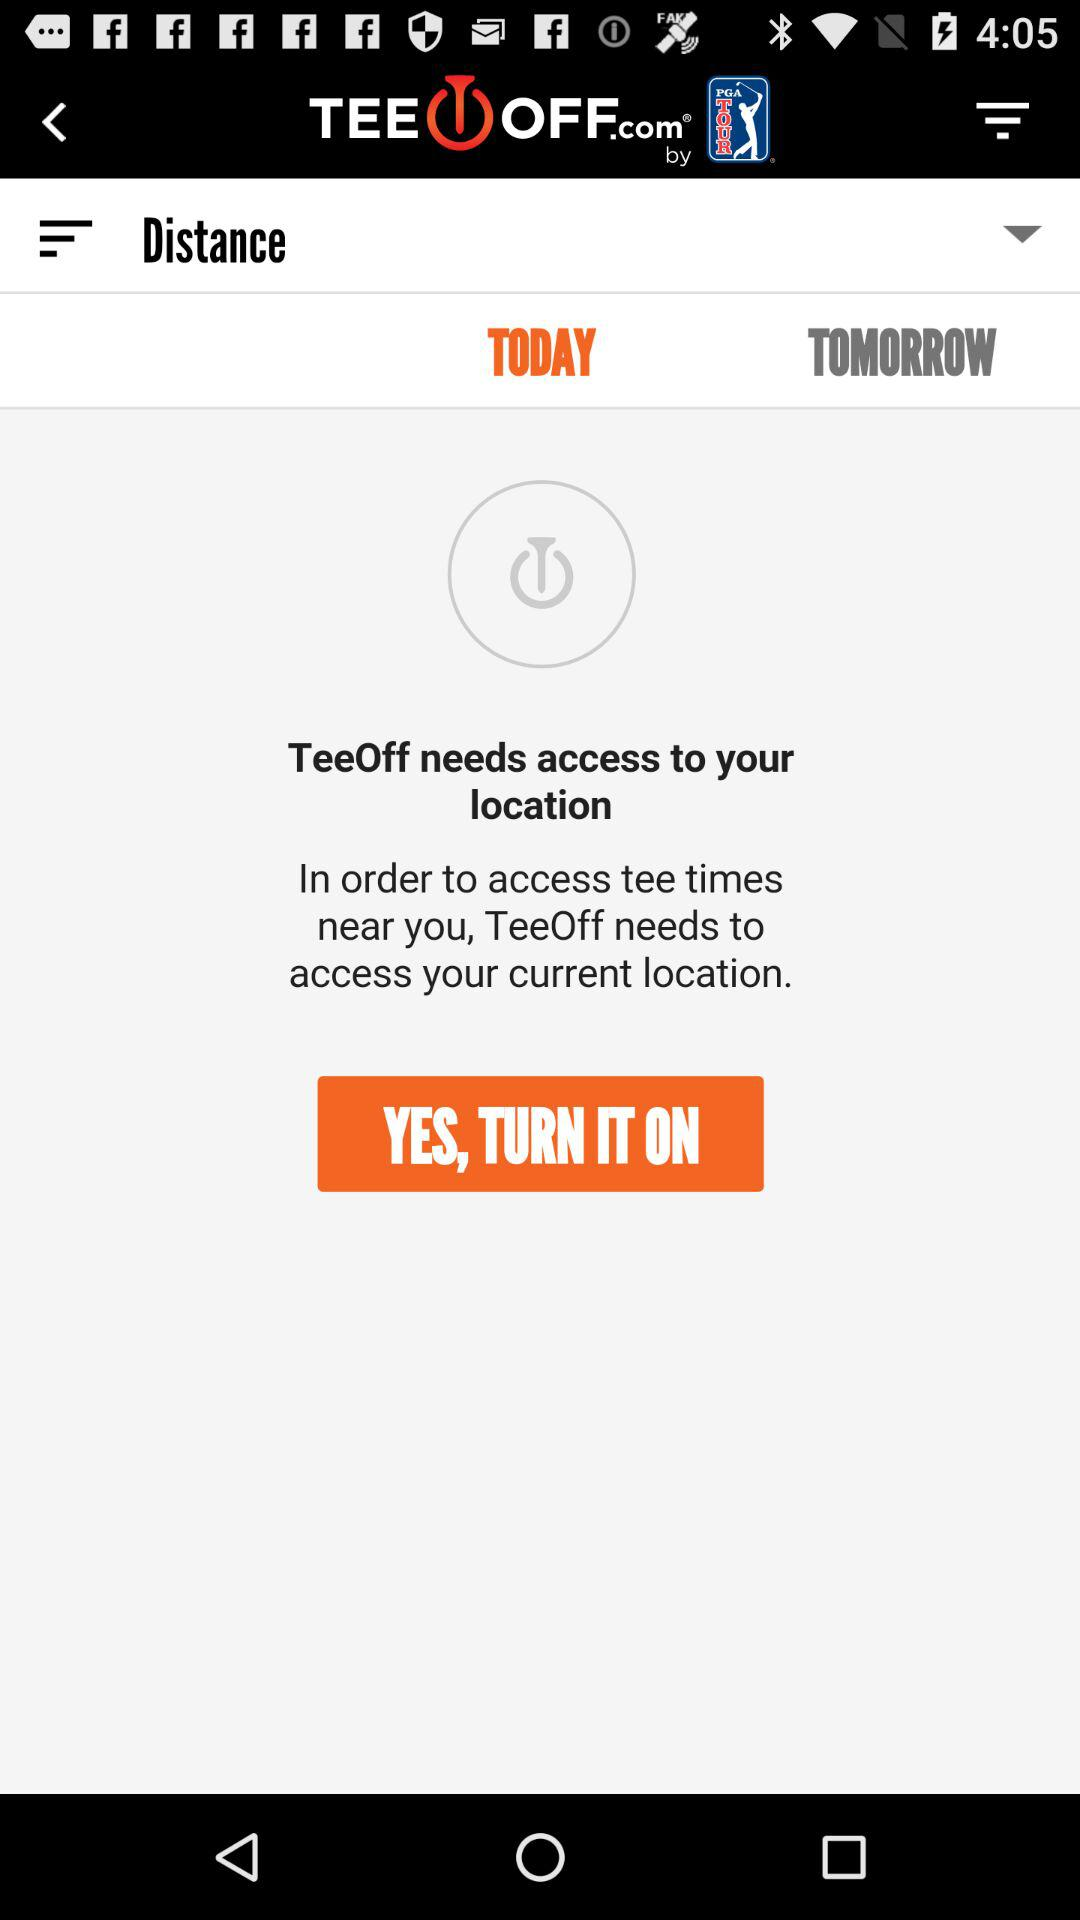What type of permission is the application asking for? The application asks for permission to use your location. 